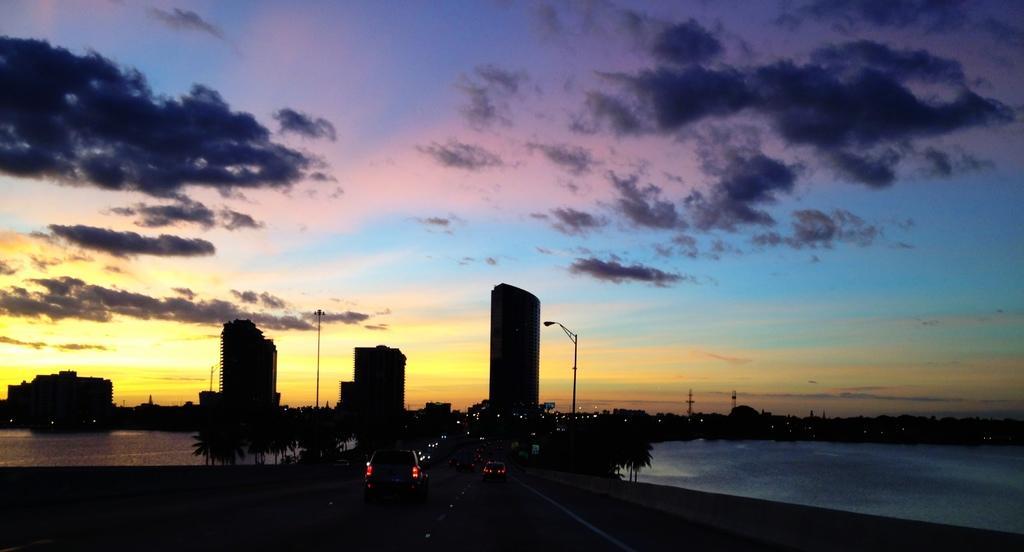In one or two sentences, can you explain what this image depicts? In this image there are some vehicles at bottom of this image and there are some trees in the background and there are some buildings as we can see in middle of this image and there is a sea at left side of this image and right side of this image as well and there is a cloudy sky at top of this image. 